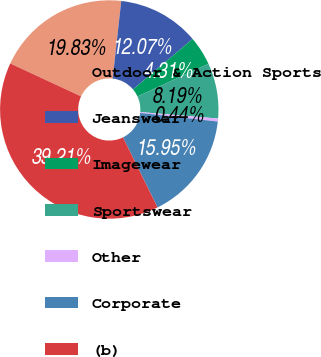Convert chart. <chart><loc_0><loc_0><loc_500><loc_500><pie_chart><fcel>Outdoor & Action Sports<fcel>Jeanswear<fcel>Imagewear<fcel>Sportswear<fcel>Other<fcel>Corporate<fcel>(b)<nl><fcel>19.83%<fcel>12.07%<fcel>4.31%<fcel>8.19%<fcel>0.44%<fcel>15.95%<fcel>39.21%<nl></chart> 